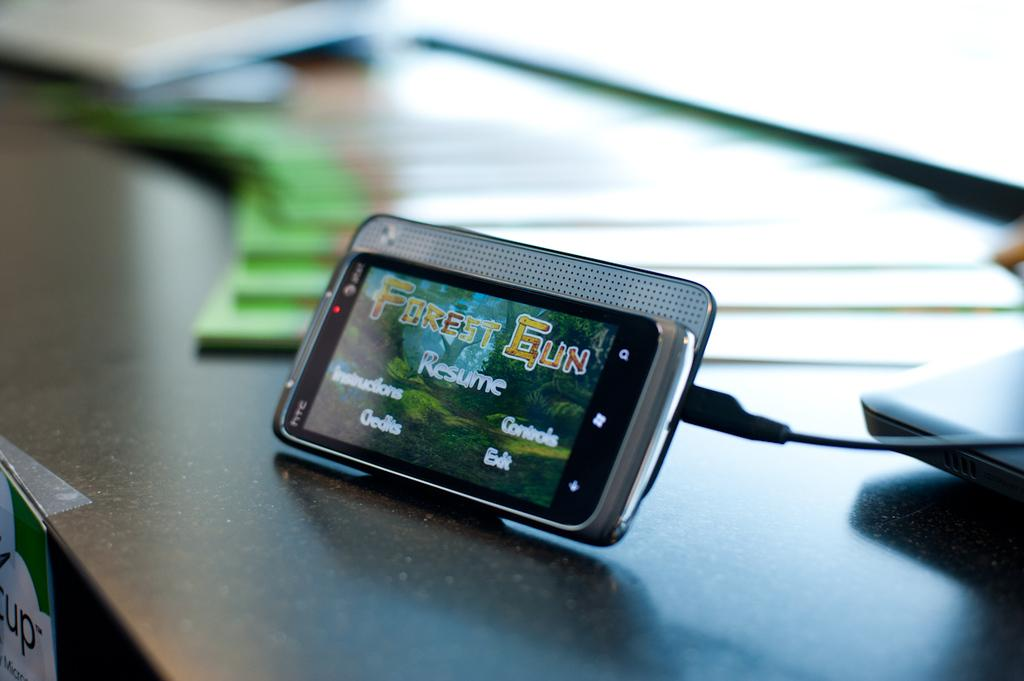<image>
Give a short and clear explanation of the subsequent image. A phone has on pause the game Forest Gun. 